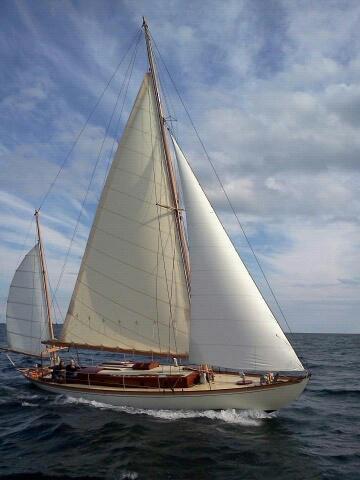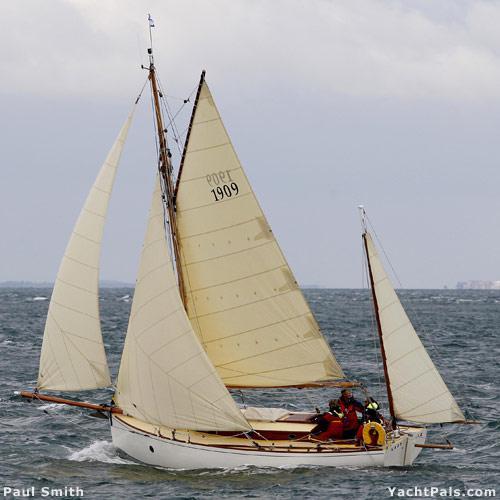The first image is the image on the left, the second image is the image on the right. For the images displayed, is the sentence "At least one of the boats has a white hull." factually correct? Answer yes or no. Yes. 